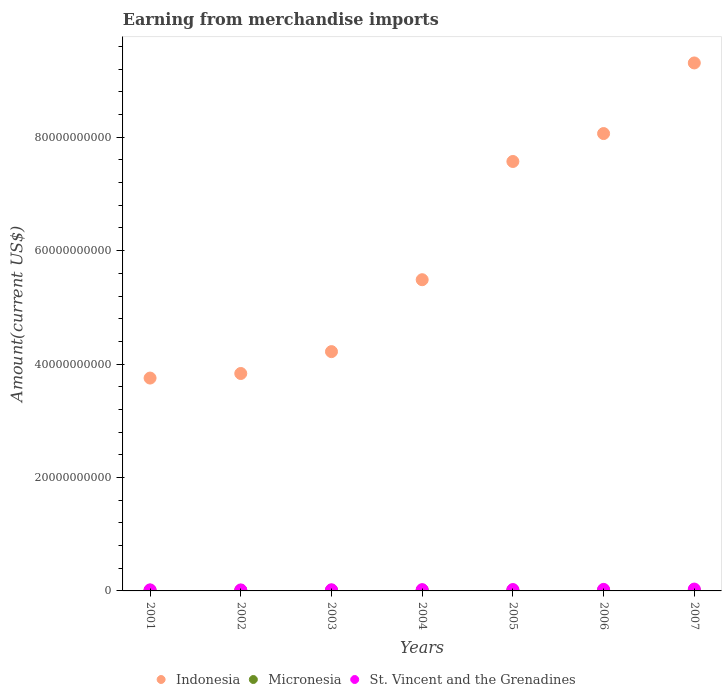Is the number of dotlines equal to the number of legend labels?
Your answer should be very brief. Yes. What is the amount earned from merchandise imports in Micronesia in 2001?
Provide a succinct answer. 1.14e+08. Across all years, what is the maximum amount earned from merchandise imports in Micronesia?
Offer a very short reply. 1.42e+08. Across all years, what is the minimum amount earned from merchandise imports in St. Vincent and the Grenadines?
Your answer should be compact. 1.74e+08. In which year was the amount earned from merchandise imports in Micronesia minimum?
Provide a short and direct response. 2002. What is the total amount earned from merchandise imports in St. Vincent and the Grenadines in the graph?
Make the answer very short. 1.63e+09. What is the difference between the amount earned from merchandise imports in Micronesia in 2002 and that in 2006?
Give a very brief answer. -3.25e+07. What is the difference between the amount earned from merchandise imports in Indonesia in 2006 and the amount earned from merchandise imports in Micronesia in 2002?
Provide a succinct answer. 8.05e+1. What is the average amount earned from merchandise imports in Micronesia per year?
Your answer should be compact. 1.25e+08. In the year 2003, what is the difference between the amount earned from merchandise imports in Micronesia and amount earned from merchandise imports in St. Vincent and the Grenadines?
Make the answer very short. -8.32e+07. In how many years, is the amount earned from merchandise imports in Indonesia greater than 32000000000 US$?
Offer a very short reply. 7. What is the ratio of the amount earned from merchandise imports in Micronesia in 2003 to that in 2007?
Ensure brevity in your answer.  0.83. Is the amount earned from merchandise imports in Indonesia in 2001 less than that in 2006?
Ensure brevity in your answer.  Yes. What is the difference between the highest and the second highest amount earned from merchandise imports in St. Vincent and the Grenadines?
Your answer should be very brief. 5.54e+07. What is the difference between the highest and the lowest amount earned from merchandise imports in Micronesia?
Give a very brief answer. 3.72e+07. In how many years, is the amount earned from merchandise imports in Indonesia greater than the average amount earned from merchandise imports in Indonesia taken over all years?
Offer a terse response. 3. Does the amount earned from merchandise imports in Micronesia monotonically increase over the years?
Offer a terse response. No. Is the amount earned from merchandise imports in Indonesia strictly greater than the amount earned from merchandise imports in Micronesia over the years?
Give a very brief answer. Yes. How many years are there in the graph?
Keep it short and to the point. 7. How are the legend labels stacked?
Make the answer very short. Horizontal. What is the title of the graph?
Your answer should be compact. Earning from merchandise imports. Does "Cuba" appear as one of the legend labels in the graph?
Ensure brevity in your answer.  No. What is the label or title of the Y-axis?
Your answer should be very brief. Amount(current US$). What is the Amount(current US$) of Indonesia in 2001?
Keep it short and to the point. 3.75e+1. What is the Amount(current US$) of Micronesia in 2001?
Provide a succinct answer. 1.14e+08. What is the Amount(current US$) in St. Vincent and the Grenadines in 2001?
Provide a succinct answer. 1.86e+08. What is the Amount(current US$) of Indonesia in 2002?
Your answer should be very brief. 3.83e+1. What is the Amount(current US$) in Micronesia in 2002?
Your answer should be compact. 1.04e+08. What is the Amount(current US$) in St. Vincent and the Grenadines in 2002?
Offer a very short reply. 1.74e+08. What is the Amount(current US$) of Indonesia in 2003?
Your answer should be very brief. 4.22e+1. What is the Amount(current US$) of Micronesia in 2003?
Ensure brevity in your answer.  1.18e+08. What is the Amount(current US$) of St. Vincent and the Grenadines in 2003?
Your answer should be compact. 2.01e+08. What is the Amount(current US$) of Indonesia in 2004?
Ensure brevity in your answer.  5.49e+1. What is the Amount(current US$) in Micronesia in 2004?
Provide a succinct answer. 1.33e+08. What is the Amount(current US$) in St. Vincent and the Grenadines in 2004?
Your response must be concise. 2.26e+08. What is the Amount(current US$) in Indonesia in 2005?
Your response must be concise. 7.57e+1. What is the Amount(current US$) in Micronesia in 2005?
Provide a succinct answer. 1.30e+08. What is the Amount(current US$) in St. Vincent and the Grenadines in 2005?
Keep it short and to the point. 2.40e+08. What is the Amount(current US$) in Indonesia in 2006?
Give a very brief answer. 8.06e+1. What is the Amount(current US$) in Micronesia in 2006?
Offer a terse response. 1.37e+08. What is the Amount(current US$) in St. Vincent and the Grenadines in 2006?
Provide a short and direct response. 2.71e+08. What is the Amount(current US$) of Indonesia in 2007?
Your answer should be very brief. 9.31e+1. What is the Amount(current US$) of Micronesia in 2007?
Your answer should be compact. 1.42e+08. What is the Amount(current US$) in St. Vincent and the Grenadines in 2007?
Your response must be concise. 3.27e+08. Across all years, what is the maximum Amount(current US$) in Indonesia?
Offer a terse response. 9.31e+1. Across all years, what is the maximum Amount(current US$) of Micronesia?
Ensure brevity in your answer.  1.42e+08. Across all years, what is the maximum Amount(current US$) of St. Vincent and the Grenadines?
Offer a terse response. 3.27e+08. Across all years, what is the minimum Amount(current US$) of Indonesia?
Provide a short and direct response. 3.75e+1. Across all years, what is the minimum Amount(current US$) of Micronesia?
Provide a short and direct response. 1.04e+08. Across all years, what is the minimum Amount(current US$) in St. Vincent and the Grenadines?
Offer a very short reply. 1.74e+08. What is the total Amount(current US$) of Indonesia in the graph?
Keep it short and to the point. 4.22e+11. What is the total Amount(current US$) of Micronesia in the graph?
Make the answer very short. 8.77e+08. What is the total Amount(current US$) in St. Vincent and the Grenadines in the graph?
Give a very brief answer. 1.63e+09. What is the difference between the Amount(current US$) of Indonesia in 2001 and that in 2002?
Keep it short and to the point. -8.06e+08. What is the difference between the Amount(current US$) of Micronesia in 2001 and that in 2002?
Provide a succinct answer. 9.54e+06. What is the difference between the Amount(current US$) in St. Vincent and the Grenadines in 2001 and that in 2002?
Make the answer very short. 1.19e+07. What is the difference between the Amount(current US$) in Indonesia in 2001 and that in 2003?
Make the answer very short. -4.66e+09. What is the difference between the Amount(current US$) of Micronesia in 2001 and that in 2003?
Ensure brevity in your answer.  -4.09e+06. What is the difference between the Amount(current US$) of St. Vincent and the Grenadines in 2001 and that in 2003?
Give a very brief answer. -1.52e+07. What is the difference between the Amount(current US$) in Indonesia in 2001 and that in 2004?
Keep it short and to the point. -1.73e+1. What is the difference between the Amount(current US$) of Micronesia in 2001 and that in 2004?
Ensure brevity in your answer.  -1.89e+07. What is the difference between the Amount(current US$) of St. Vincent and the Grenadines in 2001 and that in 2004?
Give a very brief answer. -3.96e+07. What is the difference between the Amount(current US$) in Indonesia in 2001 and that in 2005?
Your response must be concise. -3.82e+1. What is the difference between the Amount(current US$) in Micronesia in 2001 and that in 2005?
Offer a terse response. -1.64e+07. What is the difference between the Amount(current US$) of St. Vincent and the Grenadines in 2001 and that in 2005?
Give a very brief answer. -5.45e+07. What is the difference between the Amount(current US$) of Indonesia in 2001 and that in 2006?
Keep it short and to the point. -4.31e+1. What is the difference between the Amount(current US$) of Micronesia in 2001 and that in 2006?
Your response must be concise. -2.29e+07. What is the difference between the Amount(current US$) of St. Vincent and the Grenadines in 2001 and that in 2006?
Your answer should be very brief. -8.54e+07. What is the difference between the Amount(current US$) of Indonesia in 2001 and that in 2007?
Offer a very short reply. -5.56e+1. What is the difference between the Amount(current US$) of Micronesia in 2001 and that in 2007?
Keep it short and to the point. -2.77e+07. What is the difference between the Amount(current US$) of St. Vincent and the Grenadines in 2001 and that in 2007?
Provide a short and direct response. -1.41e+08. What is the difference between the Amount(current US$) of Indonesia in 2002 and that in 2003?
Make the answer very short. -3.86e+09. What is the difference between the Amount(current US$) of Micronesia in 2002 and that in 2003?
Provide a succinct answer. -1.36e+07. What is the difference between the Amount(current US$) of St. Vincent and the Grenadines in 2002 and that in 2003?
Offer a very short reply. -2.71e+07. What is the difference between the Amount(current US$) of Indonesia in 2002 and that in 2004?
Give a very brief answer. -1.65e+1. What is the difference between the Amount(current US$) in Micronesia in 2002 and that in 2004?
Your answer should be compact. -2.84e+07. What is the difference between the Amount(current US$) of St. Vincent and the Grenadines in 2002 and that in 2004?
Offer a terse response. -5.16e+07. What is the difference between the Amount(current US$) of Indonesia in 2002 and that in 2005?
Ensure brevity in your answer.  -3.74e+1. What is the difference between the Amount(current US$) in Micronesia in 2002 and that in 2005?
Offer a very short reply. -2.59e+07. What is the difference between the Amount(current US$) of St. Vincent and the Grenadines in 2002 and that in 2005?
Your answer should be compact. -6.64e+07. What is the difference between the Amount(current US$) in Indonesia in 2002 and that in 2006?
Your answer should be compact. -4.23e+1. What is the difference between the Amount(current US$) of Micronesia in 2002 and that in 2006?
Your response must be concise. -3.25e+07. What is the difference between the Amount(current US$) of St. Vincent and the Grenadines in 2002 and that in 2006?
Offer a terse response. -9.73e+07. What is the difference between the Amount(current US$) in Indonesia in 2002 and that in 2007?
Offer a terse response. -5.48e+1. What is the difference between the Amount(current US$) in Micronesia in 2002 and that in 2007?
Ensure brevity in your answer.  -3.72e+07. What is the difference between the Amount(current US$) of St. Vincent and the Grenadines in 2002 and that in 2007?
Offer a very short reply. -1.53e+08. What is the difference between the Amount(current US$) in Indonesia in 2003 and that in 2004?
Offer a very short reply. -1.27e+1. What is the difference between the Amount(current US$) in Micronesia in 2003 and that in 2004?
Provide a short and direct response. -1.48e+07. What is the difference between the Amount(current US$) in St. Vincent and the Grenadines in 2003 and that in 2004?
Ensure brevity in your answer.  -2.44e+07. What is the difference between the Amount(current US$) of Indonesia in 2003 and that in 2005?
Provide a short and direct response. -3.35e+1. What is the difference between the Amount(current US$) of Micronesia in 2003 and that in 2005?
Offer a terse response. -1.23e+07. What is the difference between the Amount(current US$) of St. Vincent and the Grenadines in 2003 and that in 2005?
Provide a short and direct response. -3.93e+07. What is the difference between the Amount(current US$) of Indonesia in 2003 and that in 2006?
Your answer should be very brief. -3.85e+1. What is the difference between the Amount(current US$) of Micronesia in 2003 and that in 2006?
Make the answer very short. -1.88e+07. What is the difference between the Amount(current US$) of St. Vincent and the Grenadines in 2003 and that in 2006?
Provide a succinct answer. -7.02e+07. What is the difference between the Amount(current US$) in Indonesia in 2003 and that in 2007?
Offer a terse response. -5.09e+1. What is the difference between the Amount(current US$) in Micronesia in 2003 and that in 2007?
Provide a short and direct response. -2.36e+07. What is the difference between the Amount(current US$) in St. Vincent and the Grenadines in 2003 and that in 2007?
Provide a short and direct response. -1.26e+08. What is the difference between the Amount(current US$) in Indonesia in 2004 and that in 2005?
Offer a terse response. -2.08e+1. What is the difference between the Amount(current US$) of Micronesia in 2004 and that in 2005?
Provide a short and direct response. 2.48e+06. What is the difference between the Amount(current US$) of St. Vincent and the Grenadines in 2004 and that in 2005?
Provide a short and direct response. -1.49e+07. What is the difference between the Amount(current US$) of Indonesia in 2004 and that in 2006?
Offer a very short reply. -2.58e+1. What is the difference between the Amount(current US$) of Micronesia in 2004 and that in 2006?
Offer a very short reply. -4.06e+06. What is the difference between the Amount(current US$) in St. Vincent and the Grenadines in 2004 and that in 2006?
Your answer should be compact. -4.58e+07. What is the difference between the Amount(current US$) of Indonesia in 2004 and that in 2007?
Provide a short and direct response. -3.82e+1. What is the difference between the Amount(current US$) in Micronesia in 2004 and that in 2007?
Ensure brevity in your answer.  -8.84e+06. What is the difference between the Amount(current US$) in St. Vincent and the Grenadines in 2004 and that in 2007?
Ensure brevity in your answer.  -1.01e+08. What is the difference between the Amount(current US$) of Indonesia in 2005 and that in 2006?
Ensure brevity in your answer.  -4.92e+09. What is the difference between the Amount(current US$) of Micronesia in 2005 and that in 2006?
Provide a short and direct response. -6.54e+06. What is the difference between the Amount(current US$) of St. Vincent and the Grenadines in 2005 and that in 2006?
Make the answer very short. -3.09e+07. What is the difference between the Amount(current US$) of Indonesia in 2005 and that in 2007?
Ensure brevity in your answer.  -1.74e+1. What is the difference between the Amount(current US$) of Micronesia in 2005 and that in 2007?
Your response must be concise. -1.13e+07. What is the difference between the Amount(current US$) of St. Vincent and the Grenadines in 2005 and that in 2007?
Offer a very short reply. -8.63e+07. What is the difference between the Amount(current US$) of Indonesia in 2006 and that in 2007?
Your response must be concise. -1.25e+1. What is the difference between the Amount(current US$) of Micronesia in 2006 and that in 2007?
Keep it short and to the point. -4.77e+06. What is the difference between the Amount(current US$) of St. Vincent and the Grenadines in 2006 and that in 2007?
Ensure brevity in your answer.  -5.54e+07. What is the difference between the Amount(current US$) in Indonesia in 2001 and the Amount(current US$) in Micronesia in 2002?
Give a very brief answer. 3.74e+1. What is the difference between the Amount(current US$) in Indonesia in 2001 and the Amount(current US$) in St. Vincent and the Grenadines in 2002?
Offer a very short reply. 3.74e+1. What is the difference between the Amount(current US$) in Micronesia in 2001 and the Amount(current US$) in St. Vincent and the Grenadines in 2002?
Give a very brief answer. -6.02e+07. What is the difference between the Amount(current US$) of Indonesia in 2001 and the Amount(current US$) of Micronesia in 2003?
Offer a very short reply. 3.74e+1. What is the difference between the Amount(current US$) in Indonesia in 2001 and the Amount(current US$) in St. Vincent and the Grenadines in 2003?
Provide a succinct answer. 3.73e+1. What is the difference between the Amount(current US$) in Micronesia in 2001 and the Amount(current US$) in St. Vincent and the Grenadines in 2003?
Offer a very short reply. -8.73e+07. What is the difference between the Amount(current US$) of Indonesia in 2001 and the Amount(current US$) of Micronesia in 2004?
Your response must be concise. 3.74e+1. What is the difference between the Amount(current US$) of Indonesia in 2001 and the Amount(current US$) of St. Vincent and the Grenadines in 2004?
Make the answer very short. 3.73e+1. What is the difference between the Amount(current US$) in Micronesia in 2001 and the Amount(current US$) in St. Vincent and the Grenadines in 2004?
Your answer should be very brief. -1.12e+08. What is the difference between the Amount(current US$) in Indonesia in 2001 and the Amount(current US$) in Micronesia in 2005?
Your answer should be very brief. 3.74e+1. What is the difference between the Amount(current US$) of Indonesia in 2001 and the Amount(current US$) of St. Vincent and the Grenadines in 2005?
Ensure brevity in your answer.  3.73e+1. What is the difference between the Amount(current US$) in Micronesia in 2001 and the Amount(current US$) in St. Vincent and the Grenadines in 2005?
Offer a very short reply. -1.27e+08. What is the difference between the Amount(current US$) in Indonesia in 2001 and the Amount(current US$) in Micronesia in 2006?
Your response must be concise. 3.74e+1. What is the difference between the Amount(current US$) in Indonesia in 2001 and the Amount(current US$) in St. Vincent and the Grenadines in 2006?
Offer a terse response. 3.73e+1. What is the difference between the Amount(current US$) of Micronesia in 2001 and the Amount(current US$) of St. Vincent and the Grenadines in 2006?
Your answer should be very brief. -1.57e+08. What is the difference between the Amount(current US$) of Indonesia in 2001 and the Amount(current US$) of Micronesia in 2007?
Your response must be concise. 3.74e+1. What is the difference between the Amount(current US$) in Indonesia in 2001 and the Amount(current US$) in St. Vincent and the Grenadines in 2007?
Your answer should be very brief. 3.72e+1. What is the difference between the Amount(current US$) of Micronesia in 2001 and the Amount(current US$) of St. Vincent and the Grenadines in 2007?
Provide a short and direct response. -2.13e+08. What is the difference between the Amount(current US$) of Indonesia in 2002 and the Amount(current US$) of Micronesia in 2003?
Provide a succinct answer. 3.82e+1. What is the difference between the Amount(current US$) of Indonesia in 2002 and the Amount(current US$) of St. Vincent and the Grenadines in 2003?
Your answer should be compact. 3.81e+1. What is the difference between the Amount(current US$) of Micronesia in 2002 and the Amount(current US$) of St. Vincent and the Grenadines in 2003?
Offer a terse response. -9.68e+07. What is the difference between the Amount(current US$) in Indonesia in 2002 and the Amount(current US$) in Micronesia in 2004?
Offer a terse response. 3.82e+1. What is the difference between the Amount(current US$) of Indonesia in 2002 and the Amount(current US$) of St. Vincent and the Grenadines in 2004?
Provide a succinct answer. 3.81e+1. What is the difference between the Amount(current US$) of Micronesia in 2002 and the Amount(current US$) of St. Vincent and the Grenadines in 2004?
Offer a very short reply. -1.21e+08. What is the difference between the Amount(current US$) in Indonesia in 2002 and the Amount(current US$) in Micronesia in 2005?
Your response must be concise. 3.82e+1. What is the difference between the Amount(current US$) in Indonesia in 2002 and the Amount(current US$) in St. Vincent and the Grenadines in 2005?
Your answer should be compact. 3.81e+1. What is the difference between the Amount(current US$) in Micronesia in 2002 and the Amount(current US$) in St. Vincent and the Grenadines in 2005?
Give a very brief answer. -1.36e+08. What is the difference between the Amount(current US$) in Indonesia in 2002 and the Amount(current US$) in Micronesia in 2006?
Keep it short and to the point. 3.82e+1. What is the difference between the Amount(current US$) in Indonesia in 2002 and the Amount(current US$) in St. Vincent and the Grenadines in 2006?
Your response must be concise. 3.81e+1. What is the difference between the Amount(current US$) of Micronesia in 2002 and the Amount(current US$) of St. Vincent and the Grenadines in 2006?
Your answer should be very brief. -1.67e+08. What is the difference between the Amount(current US$) in Indonesia in 2002 and the Amount(current US$) in Micronesia in 2007?
Provide a succinct answer. 3.82e+1. What is the difference between the Amount(current US$) of Indonesia in 2002 and the Amount(current US$) of St. Vincent and the Grenadines in 2007?
Provide a short and direct response. 3.80e+1. What is the difference between the Amount(current US$) of Micronesia in 2002 and the Amount(current US$) of St. Vincent and the Grenadines in 2007?
Keep it short and to the point. -2.22e+08. What is the difference between the Amount(current US$) of Indonesia in 2003 and the Amount(current US$) of Micronesia in 2004?
Ensure brevity in your answer.  4.21e+1. What is the difference between the Amount(current US$) in Indonesia in 2003 and the Amount(current US$) in St. Vincent and the Grenadines in 2004?
Your response must be concise. 4.20e+1. What is the difference between the Amount(current US$) in Micronesia in 2003 and the Amount(current US$) in St. Vincent and the Grenadines in 2004?
Offer a terse response. -1.08e+08. What is the difference between the Amount(current US$) of Indonesia in 2003 and the Amount(current US$) of Micronesia in 2005?
Provide a succinct answer. 4.21e+1. What is the difference between the Amount(current US$) of Indonesia in 2003 and the Amount(current US$) of St. Vincent and the Grenadines in 2005?
Give a very brief answer. 4.20e+1. What is the difference between the Amount(current US$) in Micronesia in 2003 and the Amount(current US$) in St. Vincent and the Grenadines in 2005?
Offer a terse response. -1.23e+08. What is the difference between the Amount(current US$) of Indonesia in 2003 and the Amount(current US$) of Micronesia in 2006?
Offer a terse response. 4.21e+1. What is the difference between the Amount(current US$) of Indonesia in 2003 and the Amount(current US$) of St. Vincent and the Grenadines in 2006?
Keep it short and to the point. 4.19e+1. What is the difference between the Amount(current US$) of Micronesia in 2003 and the Amount(current US$) of St. Vincent and the Grenadines in 2006?
Your answer should be very brief. -1.53e+08. What is the difference between the Amount(current US$) in Indonesia in 2003 and the Amount(current US$) in Micronesia in 2007?
Keep it short and to the point. 4.21e+1. What is the difference between the Amount(current US$) of Indonesia in 2003 and the Amount(current US$) of St. Vincent and the Grenadines in 2007?
Make the answer very short. 4.19e+1. What is the difference between the Amount(current US$) in Micronesia in 2003 and the Amount(current US$) in St. Vincent and the Grenadines in 2007?
Offer a very short reply. -2.09e+08. What is the difference between the Amount(current US$) of Indonesia in 2004 and the Amount(current US$) of Micronesia in 2005?
Your answer should be very brief. 5.47e+1. What is the difference between the Amount(current US$) in Indonesia in 2004 and the Amount(current US$) in St. Vincent and the Grenadines in 2005?
Ensure brevity in your answer.  5.46e+1. What is the difference between the Amount(current US$) of Micronesia in 2004 and the Amount(current US$) of St. Vincent and the Grenadines in 2005?
Offer a terse response. -1.08e+08. What is the difference between the Amount(current US$) in Indonesia in 2004 and the Amount(current US$) in Micronesia in 2006?
Your answer should be very brief. 5.47e+1. What is the difference between the Amount(current US$) of Indonesia in 2004 and the Amount(current US$) of St. Vincent and the Grenadines in 2006?
Provide a short and direct response. 5.46e+1. What is the difference between the Amount(current US$) of Micronesia in 2004 and the Amount(current US$) of St. Vincent and the Grenadines in 2006?
Provide a succinct answer. -1.39e+08. What is the difference between the Amount(current US$) of Indonesia in 2004 and the Amount(current US$) of Micronesia in 2007?
Your answer should be compact. 5.47e+1. What is the difference between the Amount(current US$) of Indonesia in 2004 and the Amount(current US$) of St. Vincent and the Grenadines in 2007?
Make the answer very short. 5.45e+1. What is the difference between the Amount(current US$) of Micronesia in 2004 and the Amount(current US$) of St. Vincent and the Grenadines in 2007?
Keep it short and to the point. -1.94e+08. What is the difference between the Amount(current US$) in Indonesia in 2005 and the Amount(current US$) in Micronesia in 2006?
Your answer should be compact. 7.56e+1. What is the difference between the Amount(current US$) of Indonesia in 2005 and the Amount(current US$) of St. Vincent and the Grenadines in 2006?
Provide a short and direct response. 7.55e+1. What is the difference between the Amount(current US$) of Micronesia in 2005 and the Amount(current US$) of St. Vincent and the Grenadines in 2006?
Ensure brevity in your answer.  -1.41e+08. What is the difference between the Amount(current US$) in Indonesia in 2005 and the Amount(current US$) in Micronesia in 2007?
Give a very brief answer. 7.56e+1. What is the difference between the Amount(current US$) of Indonesia in 2005 and the Amount(current US$) of St. Vincent and the Grenadines in 2007?
Keep it short and to the point. 7.54e+1. What is the difference between the Amount(current US$) in Micronesia in 2005 and the Amount(current US$) in St. Vincent and the Grenadines in 2007?
Offer a very short reply. -1.96e+08. What is the difference between the Amount(current US$) in Indonesia in 2006 and the Amount(current US$) in Micronesia in 2007?
Ensure brevity in your answer.  8.05e+1. What is the difference between the Amount(current US$) in Indonesia in 2006 and the Amount(current US$) in St. Vincent and the Grenadines in 2007?
Provide a short and direct response. 8.03e+1. What is the difference between the Amount(current US$) in Micronesia in 2006 and the Amount(current US$) in St. Vincent and the Grenadines in 2007?
Offer a very short reply. -1.90e+08. What is the average Amount(current US$) in Indonesia per year?
Offer a terse response. 6.03e+1. What is the average Amount(current US$) in Micronesia per year?
Your answer should be very brief. 1.25e+08. What is the average Amount(current US$) in St. Vincent and the Grenadines per year?
Give a very brief answer. 2.32e+08. In the year 2001, what is the difference between the Amount(current US$) of Indonesia and Amount(current US$) of Micronesia?
Offer a very short reply. 3.74e+1. In the year 2001, what is the difference between the Amount(current US$) in Indonesia and Amount(current US$) in St. Vincent and the Grenadines?
Make the answer very short. 3.73e+1. In the year 2001, what is the difference between the Amount(current US$) in Micronesia and Amount(current US$) in St. Vincent and the Grenadines?
Offer a terse response. -7.21e+07. In the year 2002, what is the difference between the Amount(current US$) of Indonesia and Amount(current US$) of Micronesia?
Offer a very short reply. 3.82e+1. In the year 2002, what is the difference between the Amount(current US$) of Indonesia and Amount(current US$) of St. Vincent and the Grenadines?
Ensure brevity in your answer.  3.82e+1. In the year 2002, what is the difference between the Amount(current US$) of Micronesia and Amount(current US$) of St. Vincent and the Grenadines?
Offer a terse response. -6.97e+07. In the year 2003, what is the difference between the Amount(current US$) of Indonesia and Amount(current US$) of Micronesia?
Ensure brevity in your answer.  4.21e+1. In the year 2003, what is the difference between the Amount(current US$) of Indonesia and Amount(current US$) of St. Vincent and the Grenadines?
Provide a short and direct response. 4.20e+1. In the year 2003, what is the difference between the Amount(current US$) of Micronesia and Amount(current US$) of St. Vincent and the Grenadines?
Your answer should be very brief. -8.32e+07. In the year 2004, what is the difference between the Amount(current US$) of Indonesia and Amount(current US$) of Micronesia?
Offer a very short reply. 5.47e+1. In the year 2004, what is the difference between the Amount(current US$) in Indonesia and Amount(current US$) in St. Vincent and the Grenadines?
Your response must be concise. 5.47e+1. In the year 2004, what is the difference between the Amount(current US$) of Micronesia and Amount(current US$) of St. Vincent and the Grenadines?
Give a very brief answer. -9.29e+07. In the year 2005, what is the difference between the Amount(current US$) in Indonesia and Amount(current US$) in Micronesia?
Make the answer very short. 7.56e+1. In the year 2005, what is the difference between the Amount(current US$) in Indonesia and Amount(current US$) in St. Vincent and the Grenadines?
Provide a short and direct response. 7.55e+1. In the year 2005, what is the difference between the Amount(current US$) in Micronesia and Amount(current US$) in St. Vincent and the Grenadines?
Your answer should be compact. -1.10e+08. In the year 2006, what is the difference between the Amount(current US$) of Indonesia and Amount(current US$) of Micronesia?
Make the answer very short. 8.05e+1. In the year 2006, what is the difference between the Amount(current US$) in Indonesia and Amount(current US$) in St. Vincent and the Grenadines?
Offer a very short reply. 8.04e+1. In the year 2006, what is the difference between the Amount(current US$) in Micronesia and Amount(current US$) in St. Vincent and the Grenadines?
Make the answer very short. -1.35e+08. In the year 2007, what is the difference between the Amount(current US$) of Indonesia and Amount(current US$) of Micronesia?
Provide a short and direct response. 9.30e+1. In the year 2007, what is the difference between the Amount(current US$) of Indonesia and Amount(current US$) of St. Vincent and the Grenadines?
Provide a succinct answer. 9.28e+1. In the year 2007, what is the difference between the Amount(current US$) in Micronesia and Amount(current US$) in St. Vincent and the Grenadines?
Give a very brief answer. -1.85e+08. What is the ratio of the Amount(current US$) in Micronesia in 2001 to that in 2002?
Give a very brief answer. 1.09. What is the ratio of the Amount(current US$) of St. Vincent and the Grenadines in 2001 to that in 2002?
Offer a very short reply. 1.07. What is the ratio of the Amount(current US$) in Indonesia in 2001 to that in 2003?
Your response must be concise. 0.89. What is the ratio of the Amount(current US$) of Micronesia in 2001 to that in 2003?
Provide a short and direct response. 0.97. What is the ratio of the Amount(current US$) in St. Vincent and the Grenadines in 2001 to that in 2003?
Make the answer very short. 0.92. What is the ratio of the Amount(current US$) of Indonesia in 2001 to that in 2004?
Give a very brief answer. 0.68. What is the ratio of the Amount(current US$) of Micronesia in 2001 to that in 2004?
Offer a terse response. 0.86. What is the ratio of the Amount(current US$) of St. Vincent and the Grenadines in 2001 to that in 2004?
Offer a very short reply. 0.82. What is the ratio of the Amount(current US$) in Indonesia in 2001 to that in 2005?
Offer a very short reply. 0.5. What is the ratio of the Amount(current US$) of Micronesia in 2001 to that in 2005?
Your response must be concise. 0.87. What is the ratio of the Amount(current US$) in St. Vincent and the Grenadines in 2001 to that in 2005?
Ensure brevity in your answer.  0.77. What is the ratio of the Amount(current US$) in Indonesia in 2001 to that in 2006?
Give a very brief answer. 0.47. What is the ratio of the Amount(current US$) of Micronesia in 2001 to that in 2006?
Offer a terse response. 0.83. What is the ratio of the Amount(current US$) of St. Vincent and the Grenadines in 2001 to that in 2006?
Offer a very short reply. 0.69. What is the ratio of the Amount(current US$) in Indonesia in 2001 to that in 2007?
Make the answer very short. 0.4. What is the ratio of the Amount(current US$) of Micronesia in 2001 to that in 2007?
Provide a succinct answer. 0.8. What is the ratio of the Amount(current US$) in St. Vincent and the Grenadines in 2001 to that in 2007?
Offer a very short reply. 0.57. What is the ratio of the Amount(current US$) of Indonesia in 2002 to that in 2003?
Ensure brevity in your answer.  0.91. What is the ratio of the Amount(current US$) of Micronesia in 2002 to that in 2003?
Keep it short and to the point. 0.88. What is the ratio of the Amount(current US$) of St. Vincent and the Grenadines in 2002 to that in 2003?
Ensure brevity in your answer.  0.87. What is the ratio of the Amount(current US$) in Indonesia in 2002 to that in 2004?
Provide a succinct answer. 0.7. What is the ratio of the Amount(current US$) in Micronesia in 2002 to that in 2004?
Provide a succinct answer. 0.79. What is the ratio of the Amount(current US$) of St. Vincent and the Grenadines in 2002 to that in 2004?
Keep it short and to the point. 0.77. What is the ratio of the Amount(current US$) of Indonesia in 2002 to that in 2005?
Make the answer very short. 0.51. What is the ratio of the Amount(current US$) in Micronesia in 2002 to that in 2005?
Your answer should be very brief. 0.8. What is the ratio of the Amount(current US$) of St. Vincent and the Grenadines in 2002 to that in 2005?
Your response must be concise. 0.72. What is the ratio of the Amount(current US$) in Indonesia in 2002 to that in 2006?
Your answer should be very brief. 0.48. What is the ratio of the Amount(current US$) in Micronesia in 2002 to that in 2006?
Offer a very short reply. 0.76. What is the ratio of the Amount(current US$) in St. Vincent and the Grenadines in 2002 to that in 2006?
Your answer should be compact. 0.64. What is the ratio of the Amount(current US$) in Indonesia in 2002 to that in 2007?
Keep it short and to the point. 0.41. What is the ratio of the Amount(current US$) in Micronesia in 2002 to that in 2007?
Your answer should be very brief. 0.74. What is the ratio of the Amount(current US$) in St. Vincent and the Grenadines in 2002 to that in 2007?
Give a very brief answer. 0.53. What is the ratio of the Amount(current US$) in Indonesia in 2003 to that in 2004?
Make the answer very short. 0.77. What is the ratio of the Amount(current US$) of Micronesia in 2003 to that in 2004?
Offer a very short reply. 0.89. What is the ratio of the Amount(current US$) of St. Vincent and the Grenadines in 2003 to that in 2004?
Your answer should be compact. 0.89. What is the ratio of the Amount(current US$) in Indonesia in 2003 to that in 2005?
Provide a succinct answer. 0.56. What is the ratio of the Amount(current US$) in Micronesia in 2003 to that in 2005?
Make the answer very short. 0.91. What is the ratio of the Amount(current US$) in St. Vincent and the Grenadines in 2003 to that in 2005?
Give a very brief answer. 0.84. What is the ratio of the Amount(current US$) of Indonesia in 2003 to that in 2006?
Offer a terse response. 0.52. What is the ratio of the Amount(current US$) in Micronesia in 2003 to that in 2006?
Offer a very short reply. 0.86. What is the ratio of the Amount(current US$) in St. Vincent and the Grenadines in 2003 to that in 2006?
Provide a succinct answer. 0.74. What is the ratio of the Amount(current US$) in Indonesia in 2003 to that in 2007?
Make the answer very short. 0.45. What is the ratio of the Amount(current US$) in Micronesia in 2003 to that in 2007?
Keep it short and to the point. 0.83. What is the ratio of the Amount(current US$) of St. Vincent and the Grenadines in 2003 to that in 2007?
Your answer should be compact. 0.62. What is the ratio of the Amount(current US$) of Indonesia in 2004 to that in 2005?
Provide a short and direct response. 0.72. What is the ratio of the Amount(current US$) of Micronesia in 2004 to that in 2005?
Your answer should be very brief. 1.02. What is the ratio of the Amount(current US$) in St. Vincent and the Grenadines in 2004 to that in 2005?
Your answer should be compact. 0.94. What is the ratio of the Amount(current US$) of Indonesia in 2004 to that in 2006?
Provide a short and direct response. 0.68. What is the ratio of the Amount(current US$) of Micronesia in 2004 to that in 2006?
Offer a terse response. 0.97. What is the ratio of the Amount(current US$) in St. Vincent and the Grenadines in 2004 to that in 2006?
Offer a terse response. 0.83. What is the ratio of the Amount(current US$) of Indonesia in 2004 to that in 2007?
Keep it short and to the point. 0.59. What is the ratio of the Amount(current US$) in Micronesia in 2004 to that in 2007?
Your answer should be compact. 0.94. What is the ratio of the Amount(current US$) in St. Vincent and the Grenadines in 2004 to that in 2007?
Offer a terse response. 0.69. What is the ratio of the Amount(current US$) in Indonesia in 2005 to that in 2006?
Give a very brief answer. 0.94. What is the ratio of the Amount(current US$) of Micronesia in 2005 to that in 2006?
Offer a very short reply. 0.95. What is the ratio of the Amount(current US$) in St. Vincent and the Grenadines in 2005 to that in 2006?
Your answer should be very brief. 0.89. What is the ratio of the Amount(current US$) of Indonesia in 2005 to that in 2007?
Provide a succinct answer. 0.81. What is the ratio of the Amount(current US$) in St. Vincent and the Grenadines in 2005 to that in 2007?
Offer a terse response. 0.74. What is the ratio of the Amount(current US$) of Indonesia in 2006 to that in 2007?
Offer a terse response. 0.87. What is the ratio of the Amount(current US$) in Micronesia in 2006 to that in 2007?
Your answer should be compact. 0.97. What is the ratio of the Amount(current US$) of St. Vincent and the Grenadines in 2006 to that in 2007?
Ensure brevity in your answer.  0.83. What is the difference between the highest and the second highest Amount(current US$) of Indonesia?
Make the answer very short. 1.25e+1. What is the difference between the highest and the second highest Amount(current US$) of Micronesia?
Keep it short and to the point. 4.77e+06. What is the difference between the highest and the second highest Amount(current US$) in St. Vincent and the Grenadines?
Your answer should be very brief. 5.54e+07. What is the difference between the highest and the lowest Amount(current US$) of Indonesia?
Your answer should be compact. 5.56e+1. What is the difference between the highest and the lowest Amount(current US$) of Micronesia?
Your response must be concise. 3.72e+07. What is the difference between the highest and the lowest Amount(current US$) of St. Vincent and the Grenadines?
Offer a terse response. 1.53e+08. 